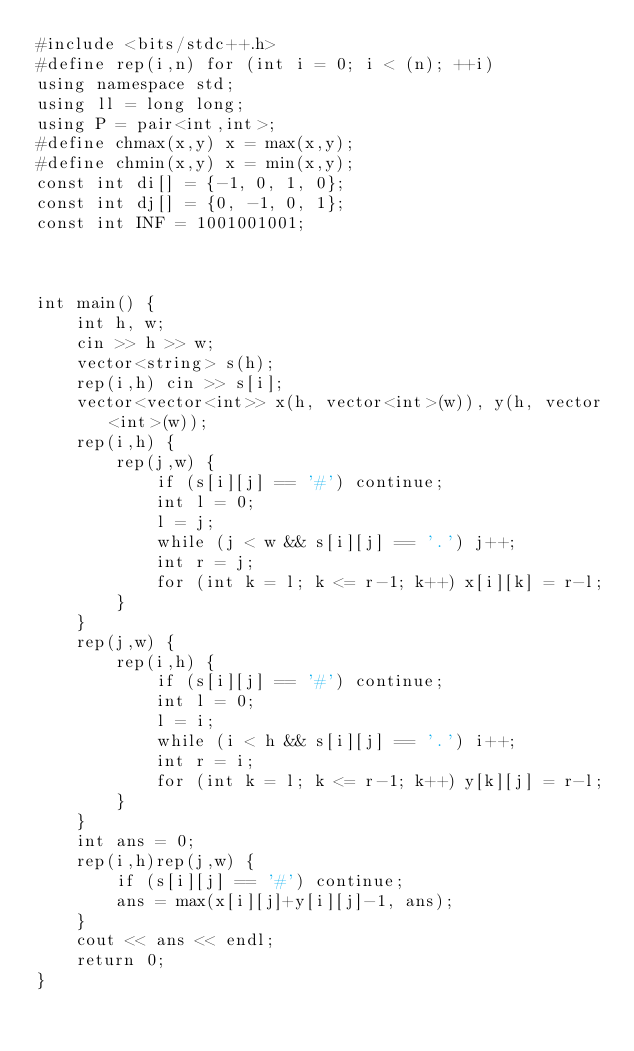Convert code to text. <code><loc_0><loc_0><loc_500><loc_500><_C++_>#include <bits/stdc++.h>
#define rep(i,n) for (int i = 0; i < (n); ++i)
using namespace std;
using ll = long long;
using P = pair<int,int>;
#define chmax(x,y) x = max(x,y);
#define chmin(x,y) x = min(x,y);
const int di[] = {-1, 0, 1, 0};
const int dj[] = {0, -1, 0, 1};
const int INF = 1001001001;



int main() {
    int h, w;
    cin >> h >> w;
    vector<string> s(h);
    rep(i,h) cin >> s[i];
    vector<vector<int>> x(h, vector<int>(w)), y(h, vector<int>(w));
    rep(i,h) {
        rep(j,w) {
            if (s[i][j] == '#') continue;
            int l = 0;
            l = j;
            while (j < w && s[i][j] == '.') j++;
            int r = j;
            for (int k = l; k <= r-1; k++) x[i][k] = r-l; 
        }
    }
    rep(j,w) {
        rep(i,h) {
            if (s[i][j] == '#') continue;
            int l = 0;
            l = i;
            while (i < h && s[i][j] == '.') i++;
            int r = i;
            for (int k = l; k <= r-1; k++) y[k][j] = r-l; 
        }
    }
    int ans = 0;
    rep(i,h)rep(j,w) {
        if (s[i][j] == '#') continue;
        ans = max(x[i][j]+y[i][j]-1, ans);
    } 
    cout << ans << endl;
    return 0;
}</code> 